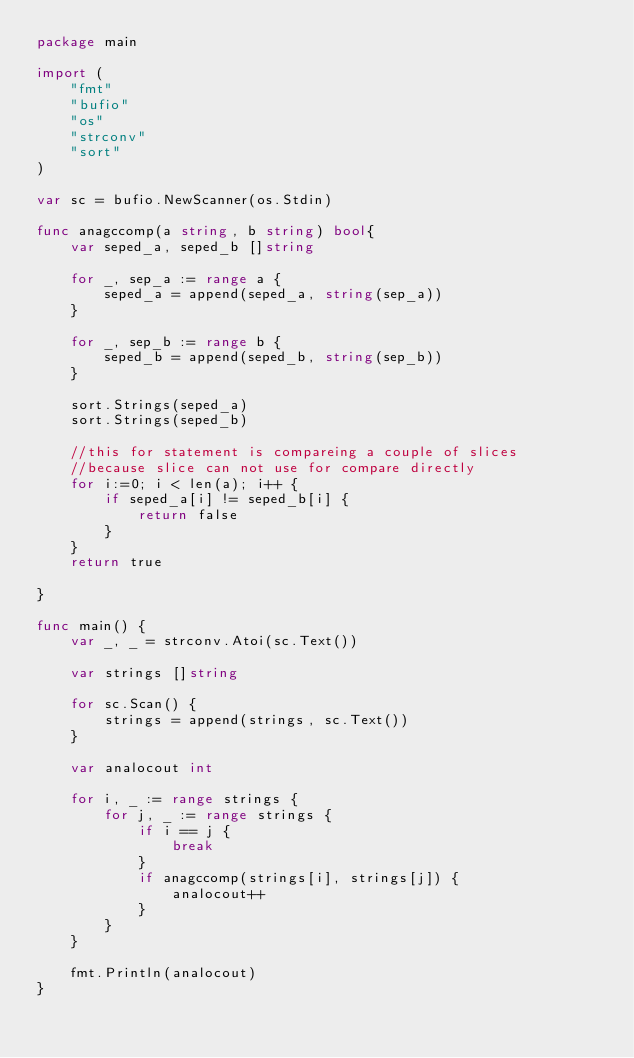Convert code to text. <code><loc_0><loc_0><loc_500><loc_500><_Go_>package main

import (
    "fmt"
    "bufio"
    "os"
    "strconv"
    "sort"
)

var sc = bufio.NewScanner(os.Stdin)

func anagccomp(a string, b string) bool{
    var seped_a, seped_b []string

    for _, sep_a := range a {
        seped_a = append(seped_a, string(sep_a))
    }

    for _, sep_b := range b {
        seped_b = append(seped_b, string(sep_b))
    }

    sort.Strings(seped_a)
    sort.Strings(seped_b)

    //this for statement is compareing a couple of slices
    //because slice can not use for compare directly
    for i:=0; i < len(a); i++ {
        if seped_a[i] != seped_b[i] {
            return false
        }
    }
    return true

}

func main() {
    var _, _ = strconv.Atoi(sc.Text())

    var strings []string

    for sc.Scan() {
        strings = append(strings, sc.Text())
    }

    var analocout int

    for i, _ := range strings {
        for j, _ := range strings {
            if i == j {
                break
            }
            if anagccomp(strings[i], strings[j]) {
                analocout++
            }
        }
    }

    fmt.Println(analocout)
}
</code> 